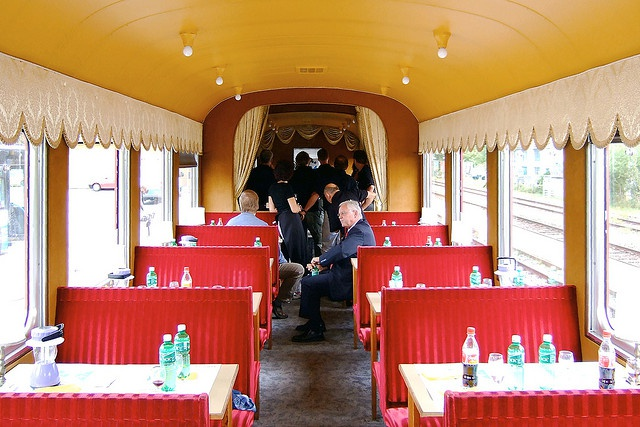Describe the objects in this image and their specific colors. I can see train in white, orange, brown, and tan tones, bench in orange, red, brown, and salmon tones, bench in orange, brown, and maroon tones, bench in orange, red, brown, and salmon tones, and dining table in orange, white, khaki, tan, and darkgray tones in this image. 